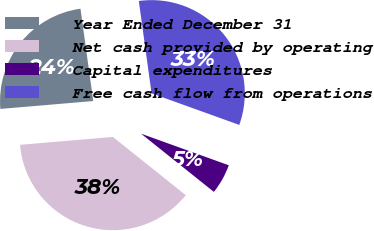Convert chart. <chart><loc_0><loc_0><loc_500><loc_500><pie_chart><fcel>Year Ended December 31<fcel>Net cash provided by operating<fcel>Capital expenditures<fcel>Free cash flow from operations<nl><fcel>24.16%<fcel>37.92%<fcel>5.23%<fcel>32.69%<nl></chart> 